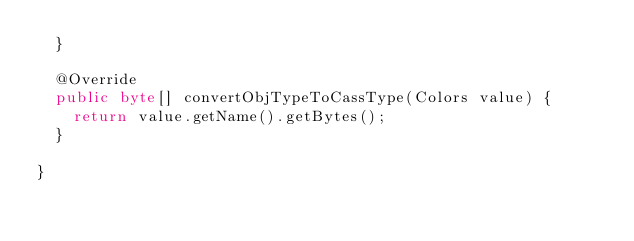<code> <loc_0><loc_0><loc_500><loc_500><_Java_>  }

  @Override
  public byte[] convertObjTypeToCassType(Colors value) {
    return value.getName().getBytes();
  }

}
</code> 